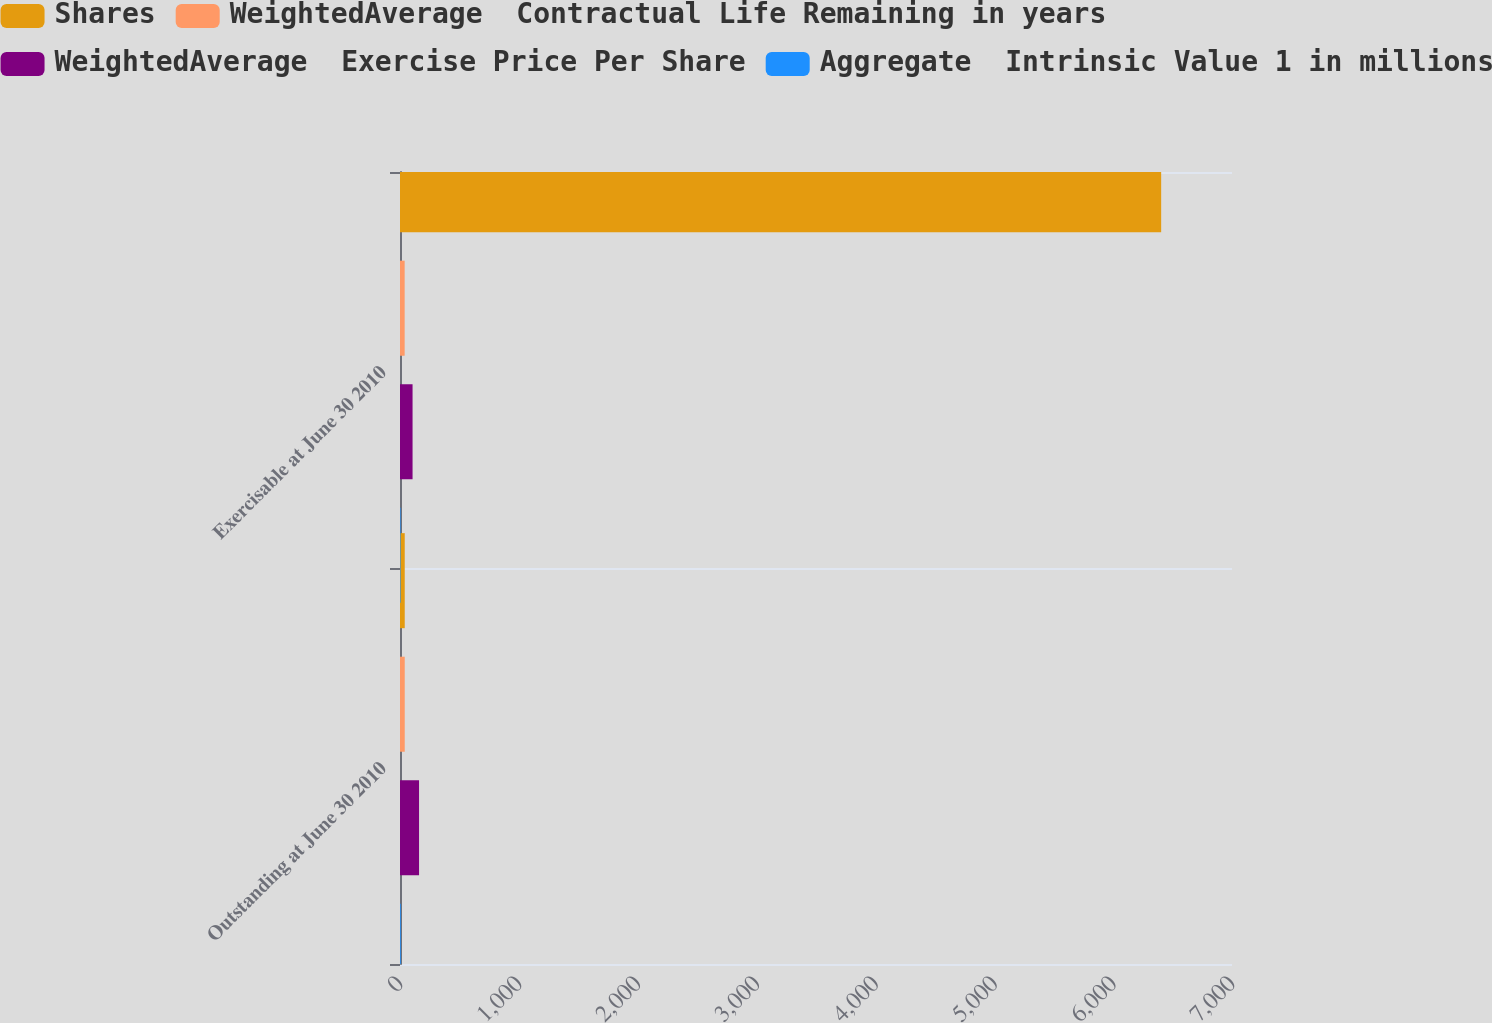<chart> <loc_0><loc_0><loc_500><loc_500><stacked_bar_chart><ecel><fcel>Outstanding at June 30 2010<fcel>Exercisable at June 30 2010<nl><fcel>Shares<fcel>39.84<fcel>6404<nl><fcel>WeightedAverage  Contractual Life Remaining in years<fcel>39.84<fcel>39.22<nl><fcel>WeightedAverage  Exercise Price Per Share<fcel>160.3<fcel>105.7<nl><fcel>Aggregate  Intrinsic Value 1 in millions<fcel>6.1<fcel>4.6<nl></chart> 